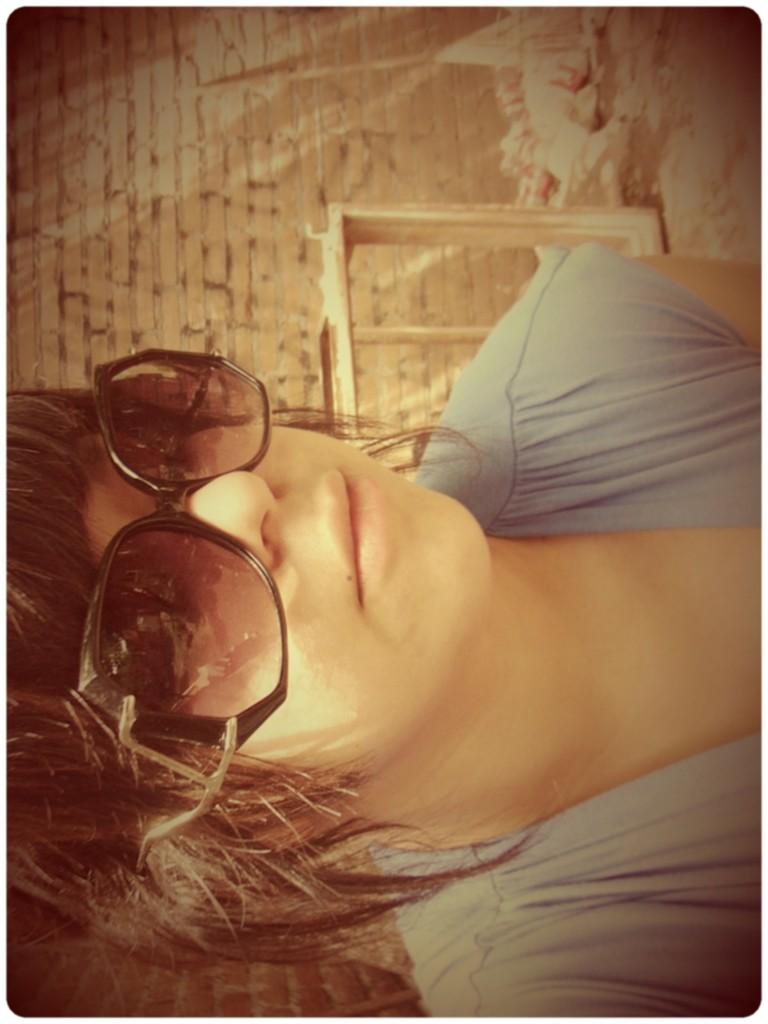Who is present in the image? There is a woman in the image. What is the woman wearing on her face? The woman is wearing goggles. What can be seen behind the woman in the image? There is a wall in the background of the image. What else is visible in the background of the image? There are objects visible in the background of the image. What type of wool is being spun by the insect in the image? There is no insect or wool present in the image. What time of day is it in the image, based on the hour? The provided facts do not mention the time of day or any specific hour, so it cannot be determined from the image. 